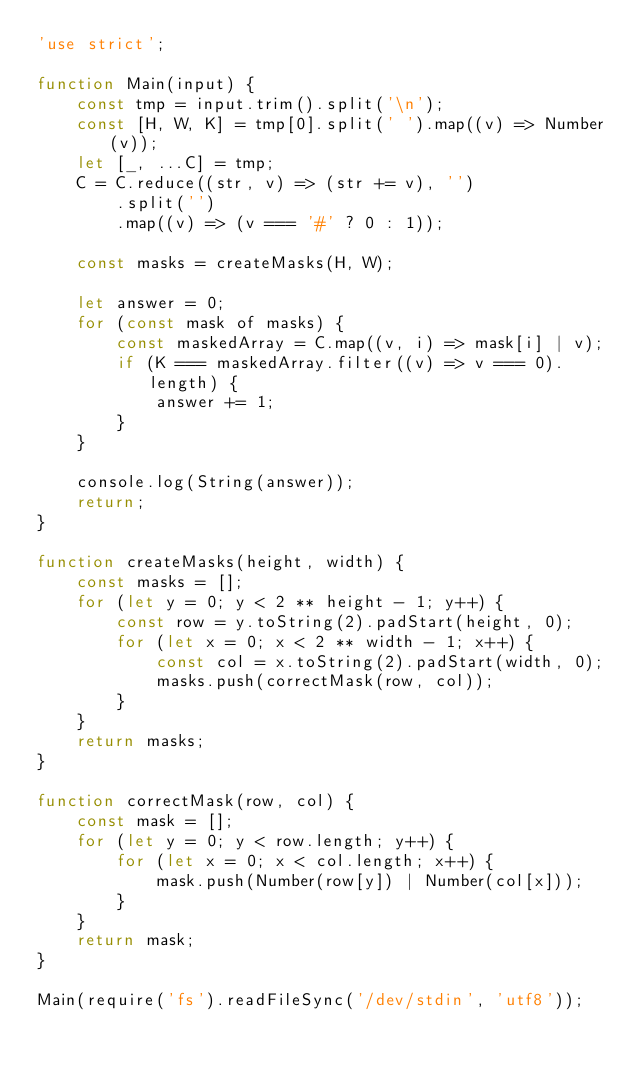Convert code to text. <code><loc_0><loc_0><loc_500><loc_500><_JavaScript_>'use strict';

function Main(input) {
    const tmp = input.trim().split('\n');
    const [H, W, K] = tmp[0].split(' ').map((v) => Number(v));
    let [_, ...C] = tmp;
    C = C.reduce((str, v) => (str += v), '')
        .split('')
        .map((v) => (v === '#' ? 0 : 1));

    const masks = createMasks(H, W);

    let answer = 0;
    for (const mask of masks) {
        const maskedArray = C.map((v, i) => mask[i] | v);
        if (K === maskedArray.filter((v) => v === 0).length) {
            answer += 1;
        }
    }

    console.log(String(answer));
    return;
}

function createMasks(height, width) {
    const masks = [];
    for (let y = 0; y < 2 ** height - 1; y++) {
        const row = y.toString(2).padStart(height, 0);
        for (let x = 0; x < 2 ** width - 1; x++) {
            const col = x.toString(2).padStart(width, 0);
            masks.push(correctMask(row, col));
        }
    }
    return masks;
}

function correctMask(row, col) {
    const mask = [];
    for (let y = 0; y < row.length; y++) {
        for (let x = 0; x < col.length; x++) {
            mask.push(Number(row[y]) | Number(col[x]));
        }
    }
    return mask;
}

Main(require('fs').readFileSync('/dev/stdin', 'utf8'));</code> 